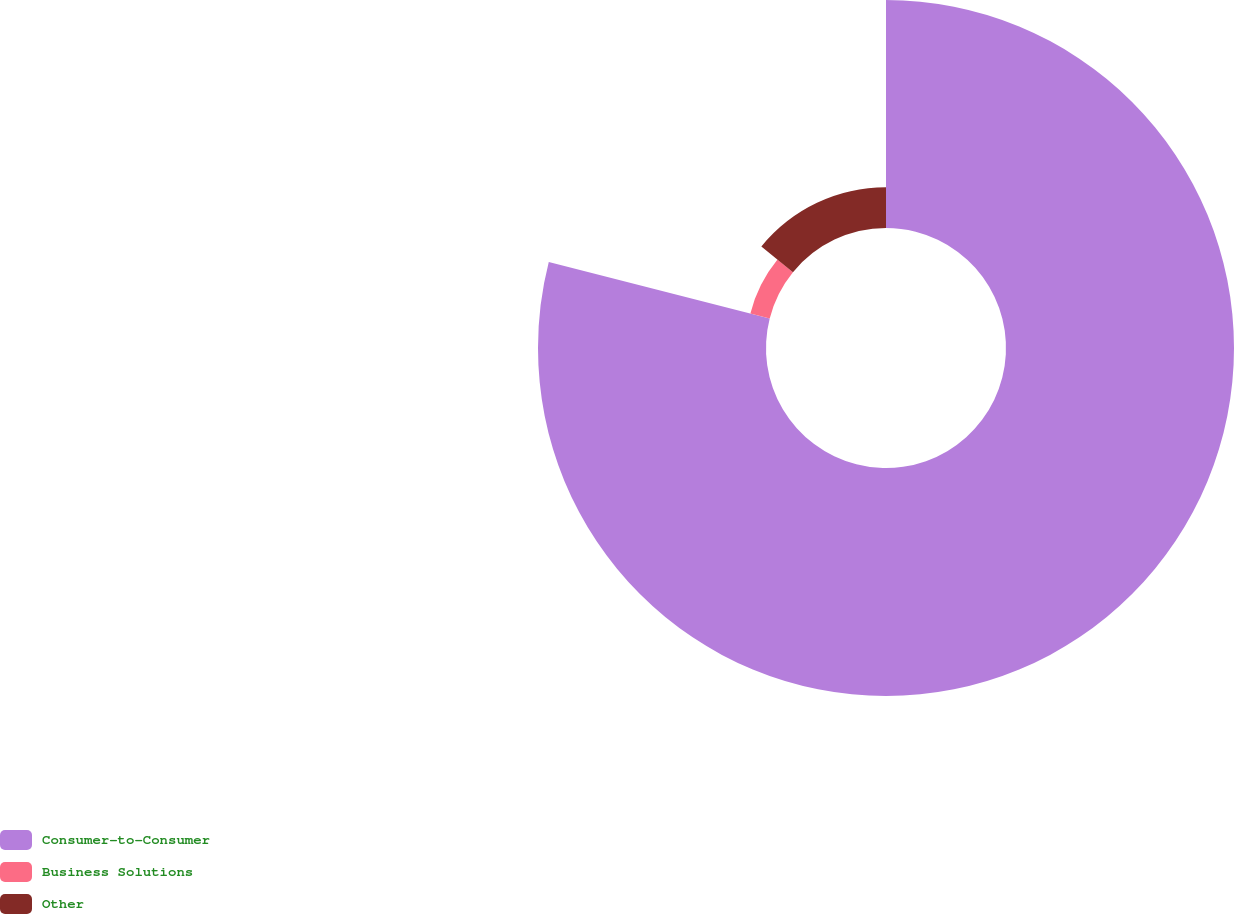Convert chart to OTSL. <chart><loc_0><loc_0><loc_500><loc_500><pie_chart><fcel>Consumer-to-Consumer<fcel>Business Solutions<fcel>Other<nl><fcel>78.97%<fcel>6.91%<fcel>14.12%<nl></chart> 